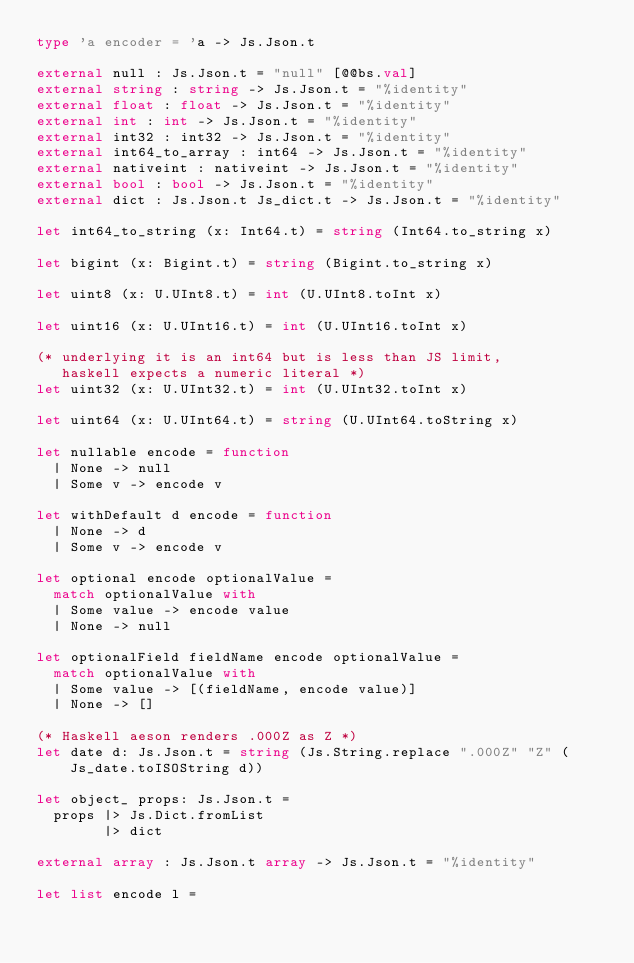Convert code to text. <code><loc_0><loc_0><loc_500><loc_500><_OCaml_>type 'a encoder = 'a -> Js.Json.t

external null : Js.Json.t = "null" [@@bs.val]
external string : string -> Js.Json.t = "%identity"
external float : float -> Js.Json.t = "%identity"
external int : int -> Js.Json.t = "%identity"
external int32 : int32 -> Js.Json.t = "%identity"
external int64_to_array : int64 -> Js.Json.t = "%identity"
external nativeint : nativeint -> Js.Json.t = "%identity"
external bool : bool -> Js.Json.t = "%identity" 
external dict : Js.Json.t Js_dict.t -> Js.Json.t = "%identity"
                                                 
let int64_to_string (x: Int64.t) = string (Int64.to_string x)
                                                 
let bigint (x: Bigint.t) = string (Bigint.to_string x)
                                                 
let uint8 (x: U.UInt8.t) = int (U.UInt8.toInt x)

let uint16 (x: U.UInt16.t) = int (U.UInt16.toInt x)

(* underlying it is an int64 but is less than JS limit,
   haskell expects a numeric literal *)                           
let uint32 (x: U.UInt32.t) = int (U.UInt32.toInt x)

let uint64 (x: U.UInt64.t) = string (U.UInt64.toString x)
  
let nullable encode = function
  | None -> null
  | Some v -> encode v

let withDefault d encode = function
  | None -> d
  | Some v -> encode v

let optional encode optionalValue =
  match optionalValue with
  | Some value -> encode value
  | None -> null

let optionalField fieldName encode optionalValue =
  match optionalValue with
  | Some value -> [(fieldName, encode value)]
  | None -> []

(* Haskell aeson renders .000Z as Z *)          
let date d: Js.Json.t = string (Js.String.replace ".000Z" "Z" (Js_date.toISOString d))
  
let object_ props: Js.Json.t =
  props |> Js.Dict.fromList
        |> dict

external array : Js.Json.t array -> Js.Json.t = "%identity"

let list encode l =</code> 